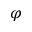<formula> <loc_0><loc_0><loc_500><loc_500>\varphi</formula> 